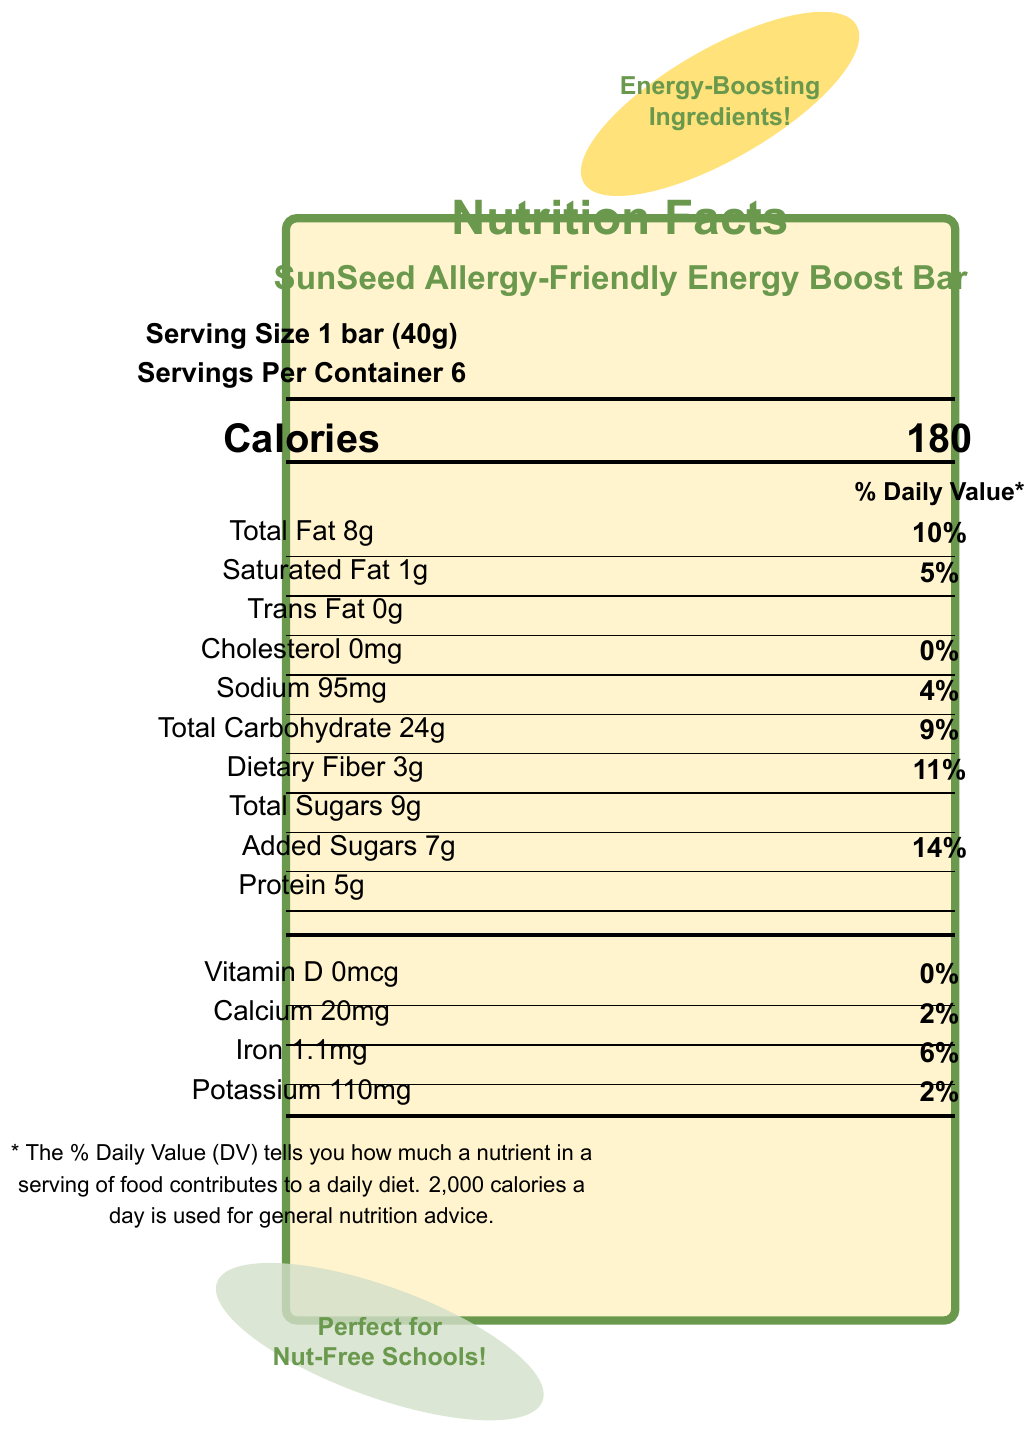what is the serving size of the granola bar? The serving size is explicitly listed as "1 bar (40g)" in the document.
Answer: 1 bar (40g) how many calories are in one serving? The calorie content per serving is stated as "180" in the document.
Answer: 180 how many grams of total fat are in one serving? The document states that there are "Total Fat 8g" per serving.
Answer: 8g how many grams of dietary fiber are in each granola bar? The dietary fiber content per serving is listed as "Dietary Fiber 3g".
Answer: 3g is this granola bar free of nuts and peanuts? The allergen information specifies that it is produced in a facility that does not process nuts or peanuts.
Answer: Yes which ingredient in the granola bar helps to provide complex carbohydrates for sustained energy? A. Brown rice syrup B. Sunflower seeds C. Whole grain oats The energy-boosting ingredient "Whole grain oats" is noted to provide complex carbohydrates for sustained energy.
Answer: C. Whole grain oats what is the percentage of daily value for added sugars in one serving? A. 5% B. 11% C. 14% D. 20% The document mentions that the added sugars contribute to "14% Daily Value".
Answer: C. 14% does the granola bar contain any trans fat? The document lists "Trans Fat 0g", indicating that there is no trans fat in the granola bar.
Answer: No what are the benefits of chia seeds in the granola bar? The energy-boosting ingredient "Chia seeds" provides omega-3 fatty acids and fiber, which help maintain stable blood sugar levels.
Answer: Contains omega-3 fatty acids and fiber for stable blood sugar levels which vitamins and minerals are detailed in the nutrition facts? The document lists the amounts and daily values for Vitamin D, Calcium, Iron, and Potassium.
Answer: Vitamin D, Calcium, Iron, Potassium is the product suitable for nut-free schools? The document includes a callout that reads, "Perfect for Nut-Free Schools," indicating its suitability.
Answer: Yes how many servings are in one container of this product? The document states "Servings Per Container: 6."
Answer: 6 which ingredient is high in magnesium and supports energy production? A. Sunflower seeds B. Pumpkin seeds C. Chia seeds Pumpkin seeds are noted to be high in magnesium, which supports energy production.
Answer: B. Pumpkin seeds summarize the main features of the SunSeed Allergy-Friendly Energy Boost Bar presented in the document. The document provides detailed nutrition facts, allergen information, and notes the benefits of specific energy-boosting ingredients, making it clear that the product is both school-friendly and nutritious.
Answer: The SunSeed Allergy-Friendly Energy Boost Bar is a nut-free, allergy-friendly granola bar designed to provide sustained energy. Each serving is 40g with 180 calories, 8g total fat, and 5g protein. It contains energy-boosting ingredients such as whole grain oats, sunflower seeds, pumpkin seeds, chia seeds, and flaxseeds. It's suitable for nut-free schools and helps keep kids full and focused during school hours. what is the manufacturing facility's policy on dairy processing? While the document mentions that the facility does not process nuts, peanuts, dairy, eggs, or soy, it does not explicitly state the policy regarding dairy beyond that.
Answer: Not enough information 